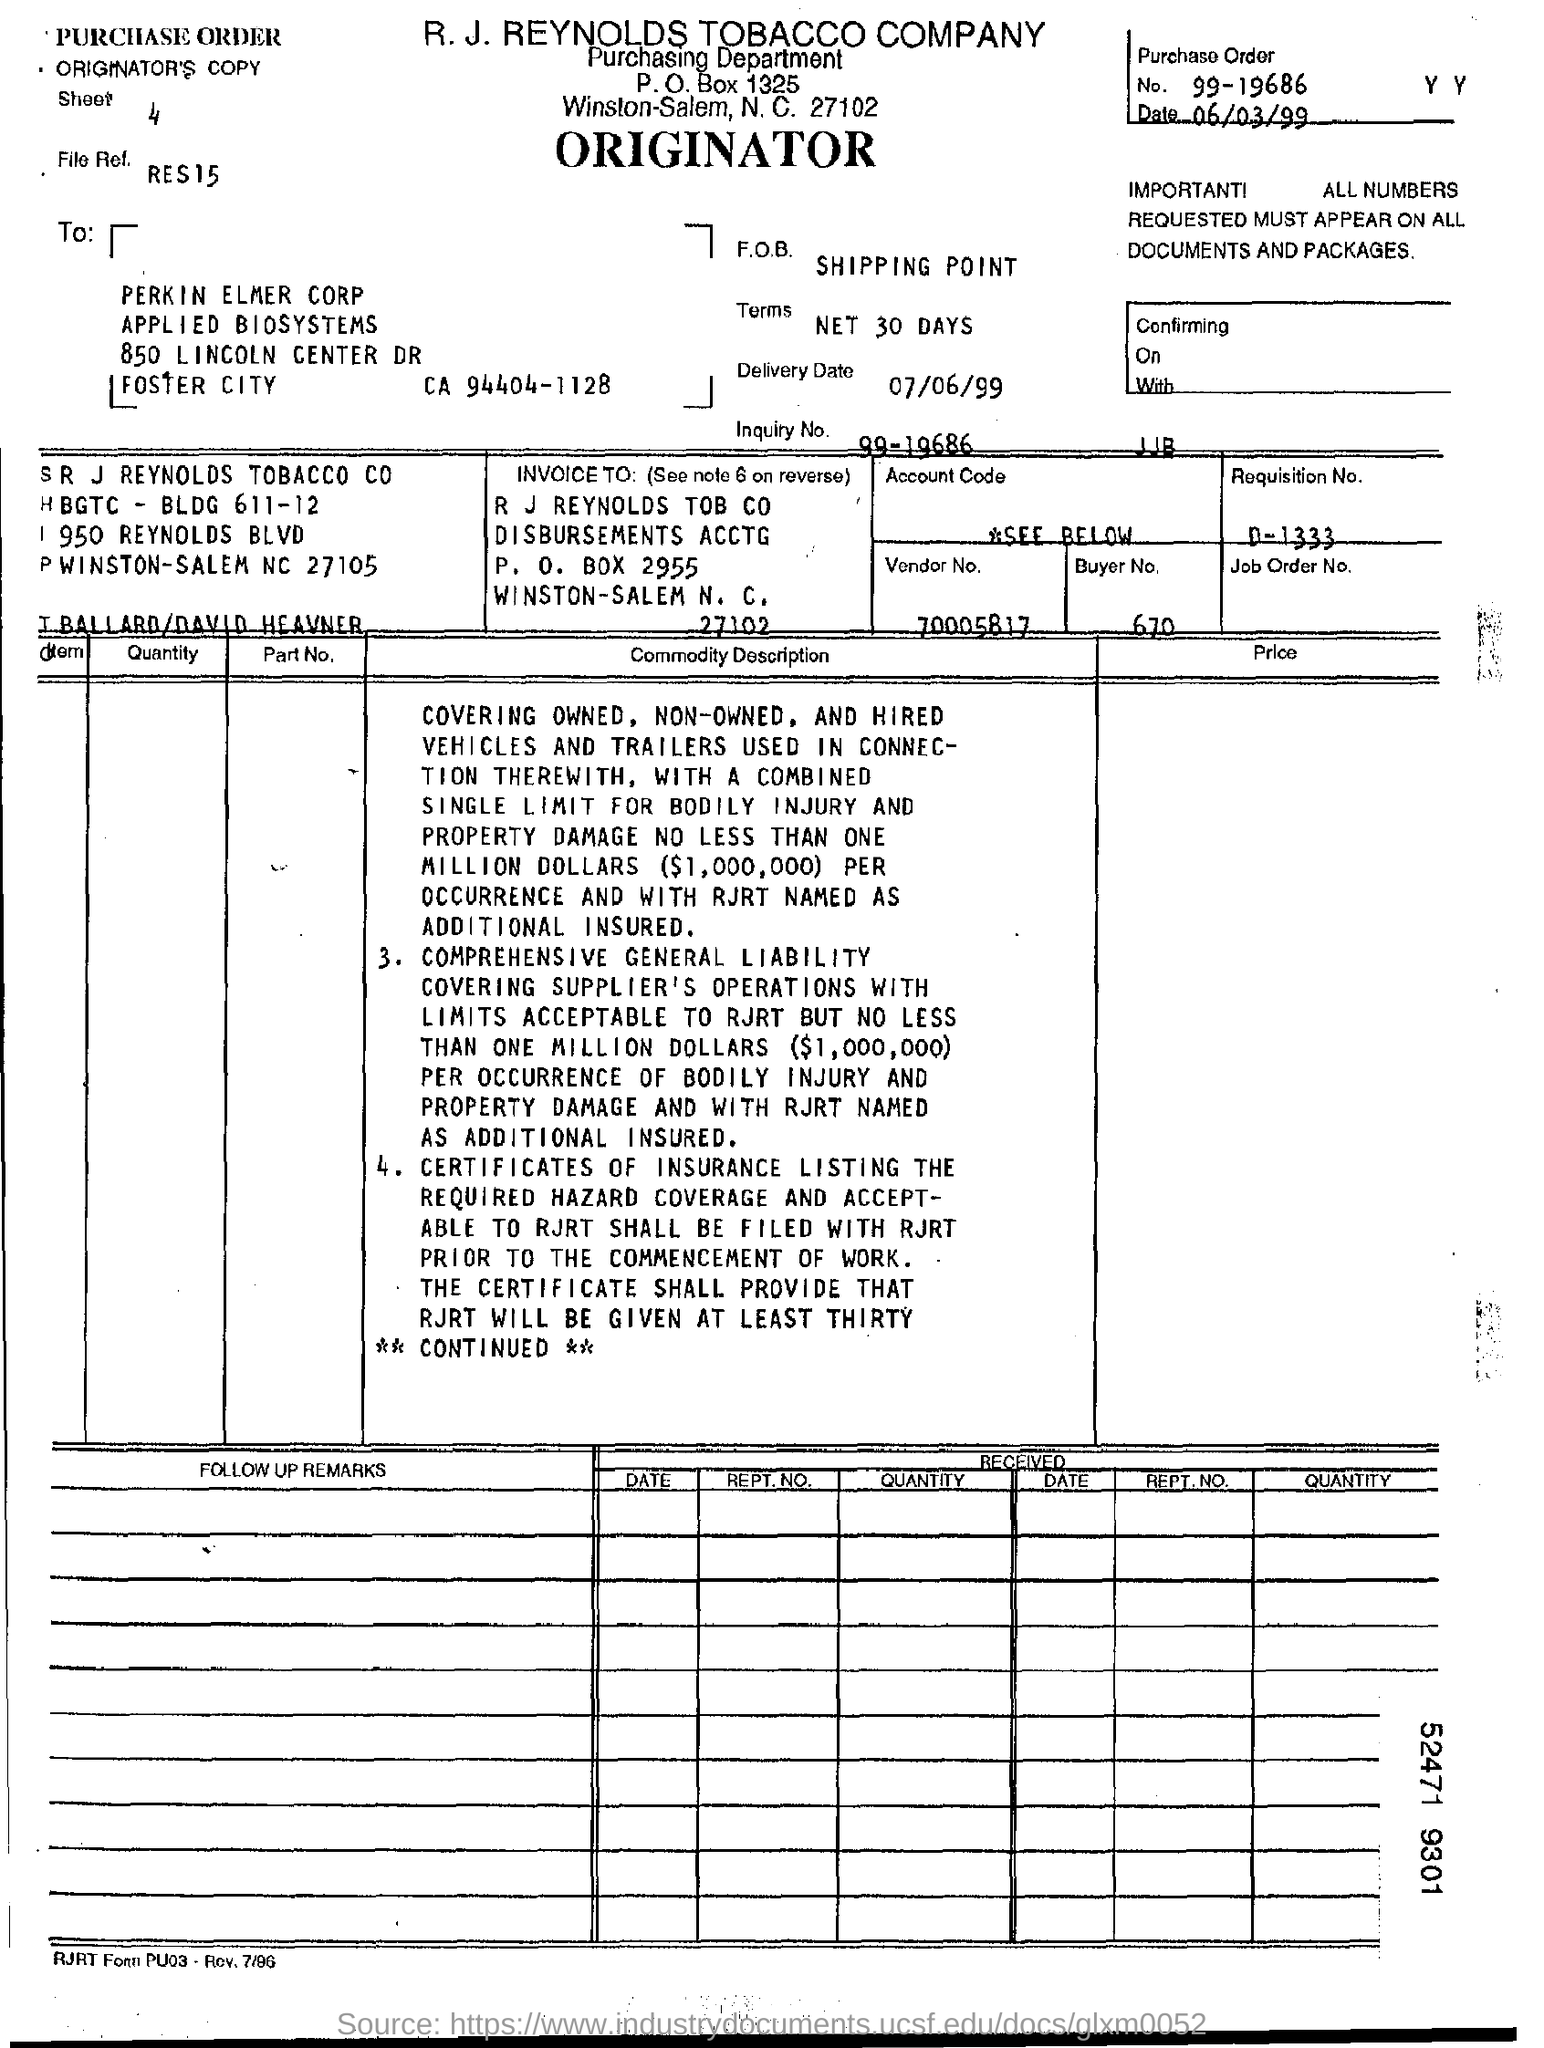What is  the delivery date ?
Your answer should be compact. 07/06/99. What is the date ?
Your response must be concise. 06/03/99. What is purchase order no ?
Provide a short and direct response. 99-19686. What is the vendor no ?
Offer a very short reply. 70005817. What is the buyer no ?
Make the answer very short. 670. To whom this bill was sent ?
Give a very brief answer. PERKIN ELMER CORP. What is the requisition no ?
Keep it short and to the point. D-1333. 